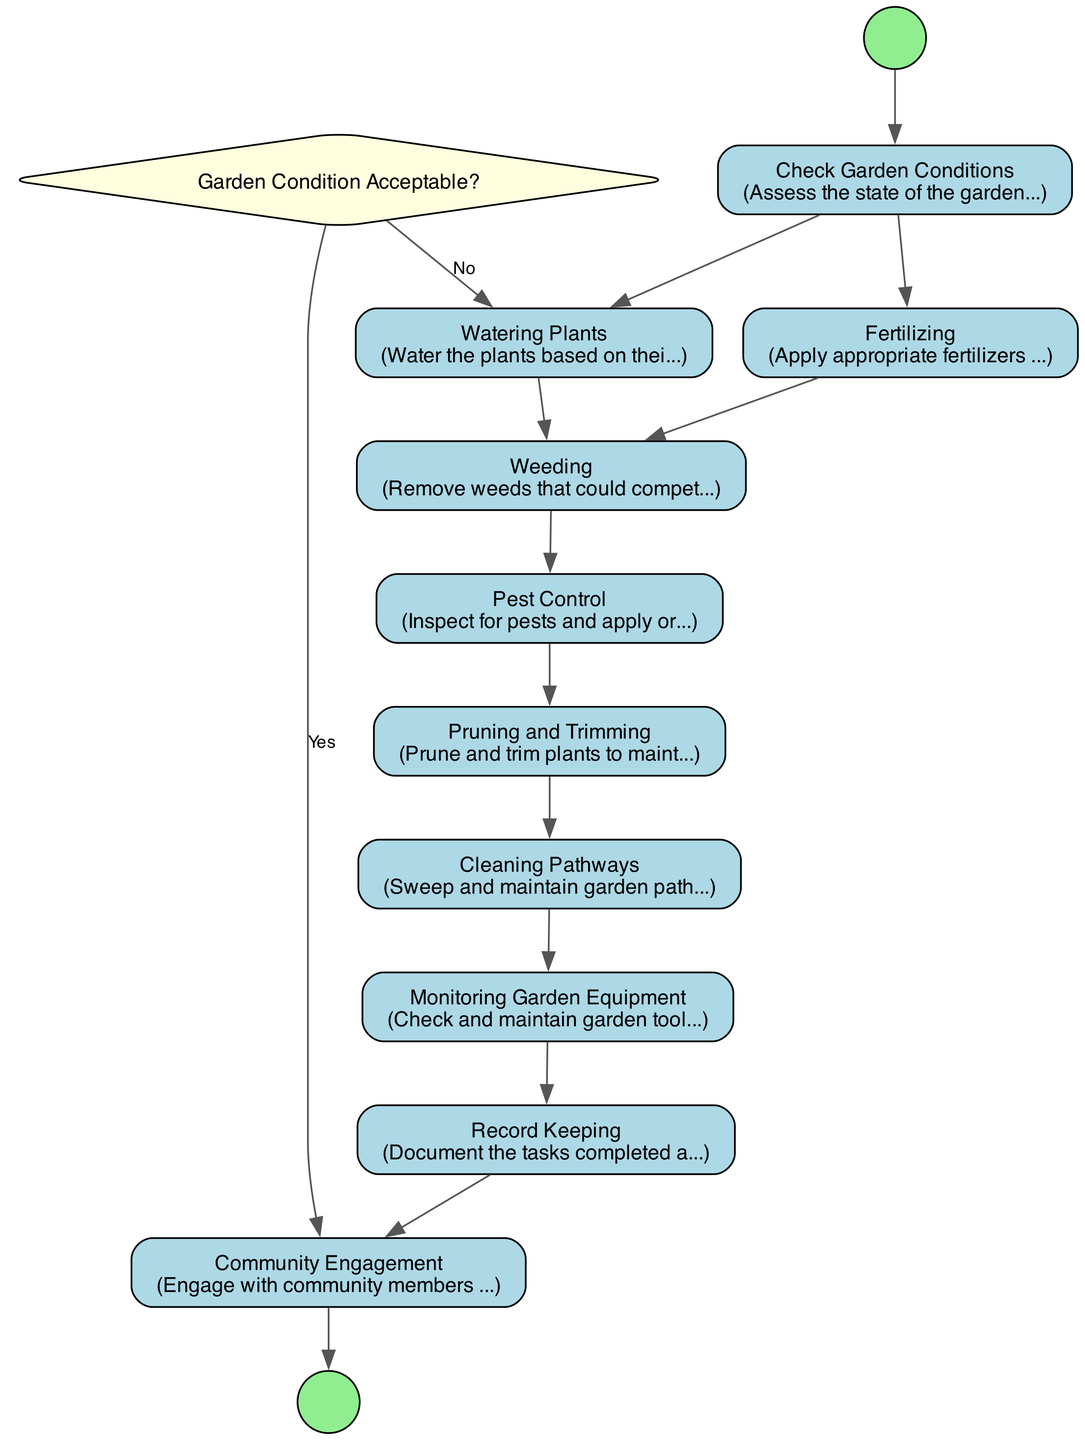What is the first activity in the diagram? The diagram starts from the node labeled "Start," which connects to the first activity, "Check Garden Conditions," indicating that this is the initial task that must be completed.
Answer: Check Garden Conditions How many activities are in the diagram? There are ten activities listed in the diagram, each corresponding to a task that must be performed in the garden maintenance and gardening process.
Answer: Ten What activity follows "Weeding"? Following the "Weeding" activity, the next activity in the flow is "Pest Control," which must be completed after weeding to ensure healthy plant maintenance.
Answer: Pest Control What decision point is included in the diagram? The decision point included in the diagram is "Garden Condition Acceptable?", which involves evaluating whether the conditions of the garden meet the set criteria for acceptance.
Answer: Garden Condition Acceptable? If the garden condition is not acceptable, what is the next activity? If the answer to the decision point "Garden Condition Acceptable?" is "No," the next activity involves "Watering Plants," which indicates that immediate action is needed to improve the garden conditions.
Answer: Watering Plants What is the last activity before community engagement? Before moving to "Community Engagement," the last recorded activity in the sequence is "Record Keeping," which involves documenting the tasks and observations made throughout the gardening process.
Answer: Record Keeping How many decision options are there at the decision point? There are two decision options at the decision point "Garden Condition Acceptable?": one for "Yes" and one for "No," indicating the possible outcomes from evaluating the garden's condition.
Answer: Two What activity must be performed before "Cleaning Pathways"? The activity that must be completed before "Cleaning Pathways" is "Pruning and Trimming," as indicated by the flow connecting these two specific activities in the maintenance process.
Answer: Pruning and Trimming What do the arrows in the diagram represent? The arrows in the diagram represent the flow of activities and decision paths, indicating the order in which tasks should be performed as well as the connections between them.
Answer: Flow of activities 